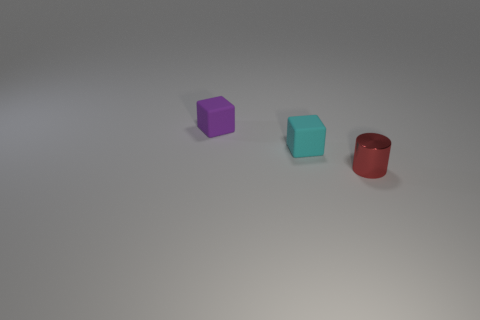Subtract all cyan cubes. How many cubes are left? 1 Subtract all blocks. How many objects are left? 1 Subtract 1 cylinders. How many cylinders are left? 0 Subtract all large green spheres. Subtract all small purple things. How many objects are left? 2 Add 1 tiny purple matte things. How many tiny purple matte things are left? 2 Add 1 big red matte things. How many big red matte things exist? 1 Add 2 purple things. How many objects exist? 5 Subtract 1 cyan cubes. How many objects are left? 2 Subtract all brown blocks. Subtract all blue cylinders. How many blocks are left? 2 Subtract all cyan spheres. How many cyan blocks are left? 1 